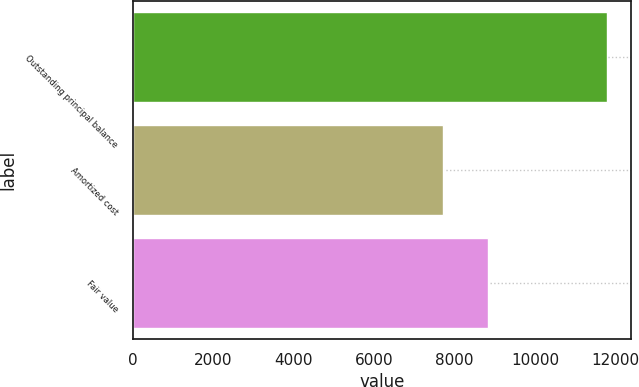Convert chart. <chart><loc_0><loc_0><loc_500><loc_500><bar_chart><fcel>Outstanding principal balance<fcel>Amortized cost<fcel>Fair value<nl><fcel>11791<fcel>7718<fcel>8823<nl></chart> 